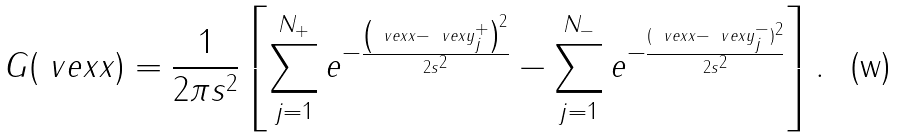<formula> <loc_0><loc_0><loc_500><loc_500>G ( \ v e x { x } ) = \frac { 1 } { 2 \pi s ^ { 2 } } \left [ \sum _ { j = 1 } ^ { N _ { + } } e ^ { - \frac { \left ( \ v e x { x } - \ v e x { y } ^ { + } _ { j } \right ) ^ { 2 } } { 2 s ^ { 2 } } } - \sum _ { j = 1 } ^ { N _ { - } } e ^ { - \frac { ( \ v e x { x } - \ v e x { y } ^ { - } _ { j } ) ^ { 2 } } { 2 s ^ { 2 } } } \right ] .</formula> 